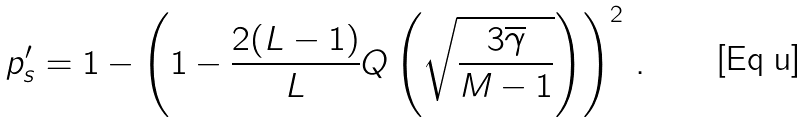<formula> <loc_0><loc_0><loc_500><loc_500>p ^ { \prime } _ { s } = 1 - \left ( 1 - \frac { 2 ( L - 1 ) } { L } Q \left ( \sqrt { \frac { 3 \overline { \gamma } } { M - 1 } } \right ) \right ) ^ { 2 } \, .</formula> 